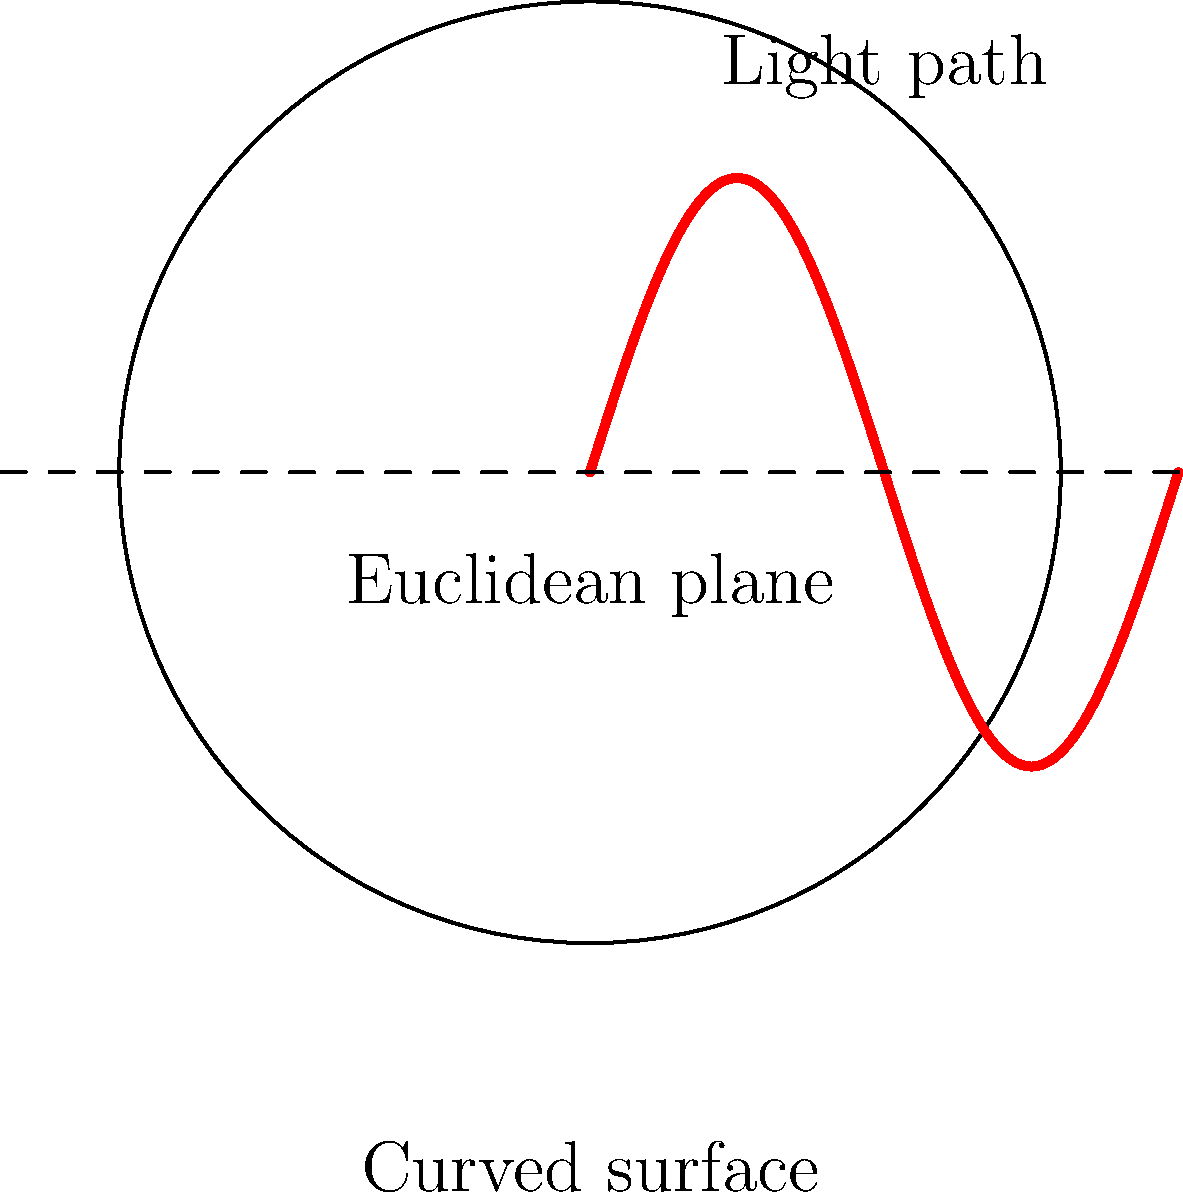In the context of non-Euclidean geometry, how does the path of light differ when traveling on a curved surface compared to a flat Euclidean plane? How might this concept be used to illustrate the disproportionate impact of corporate policies on marginalized communities? To understand this concept, let's break it down step-by-step:

1. In Euclidean geometry (flat space), light travels in straight lines. This is represented by the dashed line in the diagram.

2. In non-Euclidean geometry on a curved surface:
   a. Light follows the curvature of the surface, as shown by the red curve.
   b. The path appears curved when projected onto a flat plane.

3. This bending occurs because:
   a. Light always takes the shortest path between two points.
   b. On a curved surface, the shortest path is a geodesic, not a straight line.

4. The degree of curvature affects the amount of bending:
   a. More curvature leads to more pronounced bending.
   b. Less curvature results in paths closer to Euclidean straight lines.

5. Relating to social issues:
   a. The curved surface represents the uneven socioeconomic landscape.
   b. The light path symbolizes the flow of resources or opportunities.
   c. Just as light bends more in highly curved areas, resources and opportunities may be disproportionately redirected in areas of high socioeconomic disparity.

6. This analogy illustrates how corporate policies, like light on a curved surface, may not have straight-line (equal) effects across all communities:
   a. Some communities (represented by flatter areas) may see minimal impact.
   b. Marginalized communities (represented by more curved areas) may experience more pronounced, often negative, effects.

7. Understanding this non-linear impact is crucial for developing more equitable corporate regulations and tax policies that account for these disproportionate effects.
Answer: Light bends along geodesics on curved surfaces, unlike straight paths in Euclidean space, analogous to how corporate policies have non-uniform impacts across socioeconomic landscapes. 